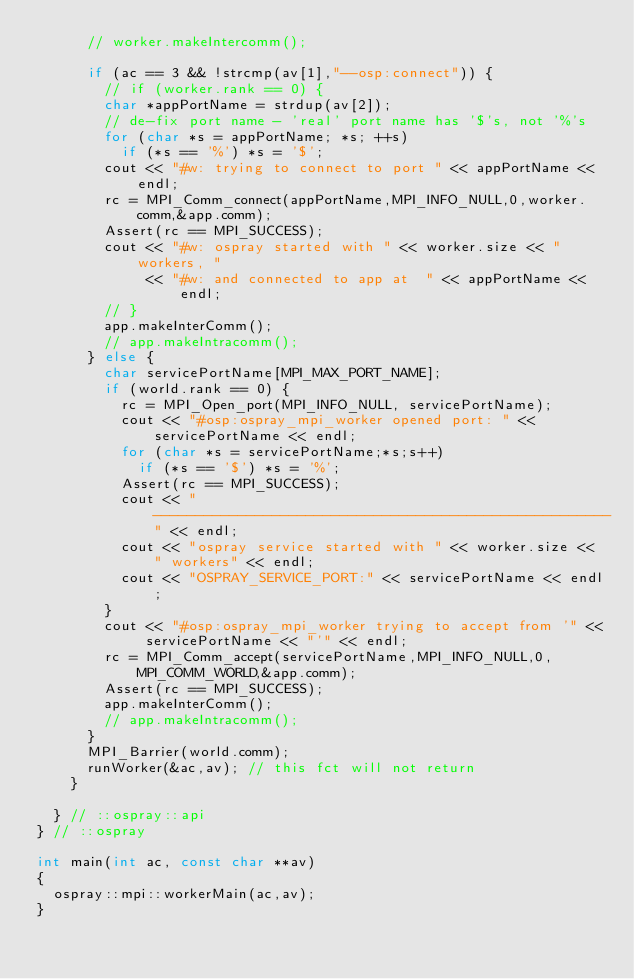Convert code to text. <code><loc_0><loc_0><loc_500><loc_500><_C++_>      // worker.makeIntercomm();

      if (ac == 3 && !strcmp(av[1],"--osp:connect")) {
        // if (worker.rank == 0) {
        char *appPortName = strdup(av[2]);
        // de-fix port name - 'real' port name has '$'s, not '%'s
        for (char *s = appPortName; *s; ++s)
          if (*s == '%') *s = '$';
        cout << "#w: trying to connect to port " << appPortName << endl;
        rc = MPI_Comm_connect(appPortName,MPI_INFO_NULL,0,worker.comm,&app.comm);
        Assert(rc == MPI_SUCCESS);
        cout << "#w: ospray started with " << worker.size << " workers, "
             << "#w: and connected to app at  " << appPortName << endl;
        // }
        app.makeInterComm();
        // app.makeIntracomm();
      } else {
        char servicePortName[MPI_MAX_PORT_NAME];
        if (world.rank == 0) {
          rc = MPI_Open_port(MPI_INFO_NULL, servicePortName);
          cout << "#osp:ospray_mpi_worker opened port: " << servicePortName << endl;
          for (char *s = servicePortName;*s;s++)
            if (*s == '$') *s = '%';
          Assert(rc == MPI_SUCCESS);
          cout << "------------------------------------------------------" << endl;
          cout << "ospray service started with " << worker.size << " workers" << endl;
          cout << "OSPRAY_SERVICE_PORT:" << servicePortName << endl;
        }
        cout << "#osp:ospray_mpi_worker trying to accept from '" << servicePortName << "'" << endl;
        rc = MPI_Comm_accept(servicePortName,MPI_INFO_NULL,0,MPI_COMM_WORLD,&app.comm);
        Assert(rc == MPI_SUCCESS);
        app.makeInterComm();
        // app.makeIntracomm();
      }
      MPI_Barrier(world.comm);
      runWorker(&ac,av); // this fct will not return
    }

  } // ::ospray::api
} // ::ospray

int main(int ac, const char **av)
{
  ospray::mpi::workerMain(ac,av);
}
</code> 